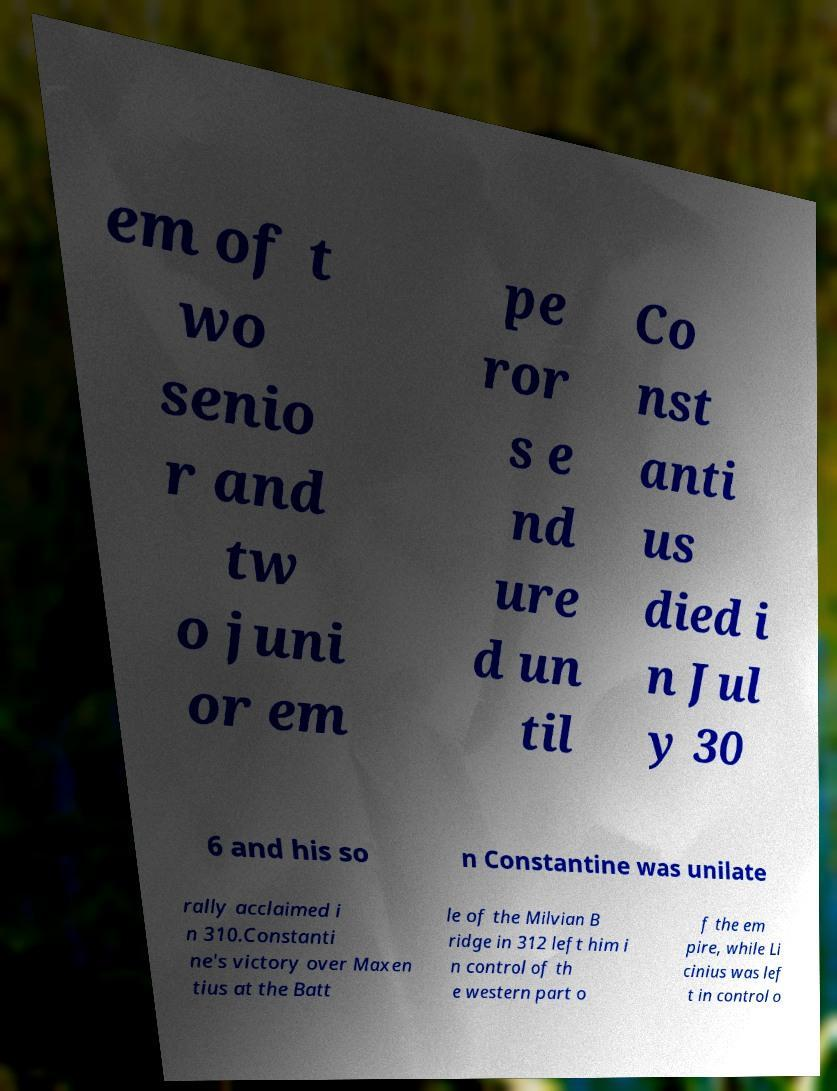Please identify and transcribe the text found in this image. em of t wo senio r and tw o juni or em pe ror s e nd ure d un til Co nst anti us died i n Jul y 30 6 and his so n Constantine was unilate rally acclaimed i n 310.Constanti ne's victory over Maxen tius at the Batt le of the Milvian B ridge in 312 left him i n control of th e western part o f the em pire, while Li cinius was lef t in control o 